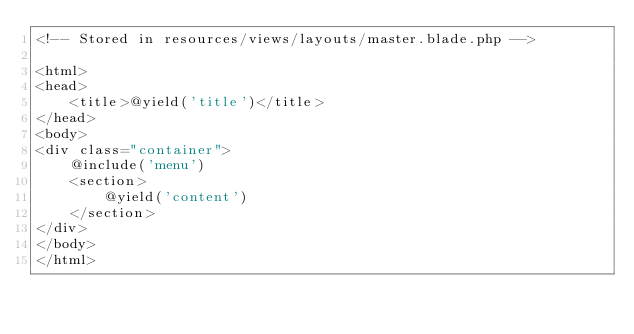<code> <loc_0><loc_0><loc_500><loc_500><_PHP_><!-- Stored in resources/views/layouts/master.blade.php -->

<html>
<head>
    <title>@yield('title')</title>
</head>
<body>
<div class="container">
    @include('menu')
    <section>
        @yield('content')
    </section>
</div>
</body>
</html></code> 